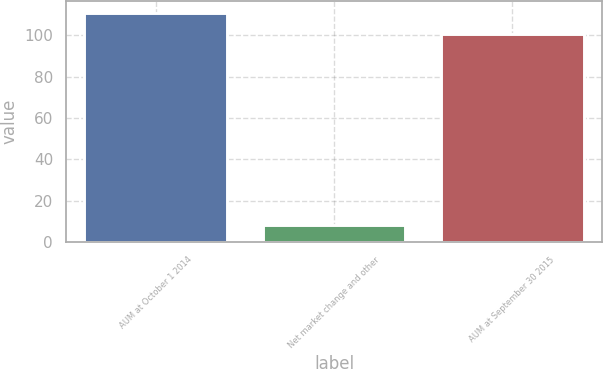<chart> <loc_0><loc_0><loc_500><loc_500><bar_chart><fcel>AUM at October 1 2014<fcel>Net market change and other<fcel>AUM at September 30 2015<nl><fcel>110.91<fcel>8.4<fcel>100.8<nl></chart> 